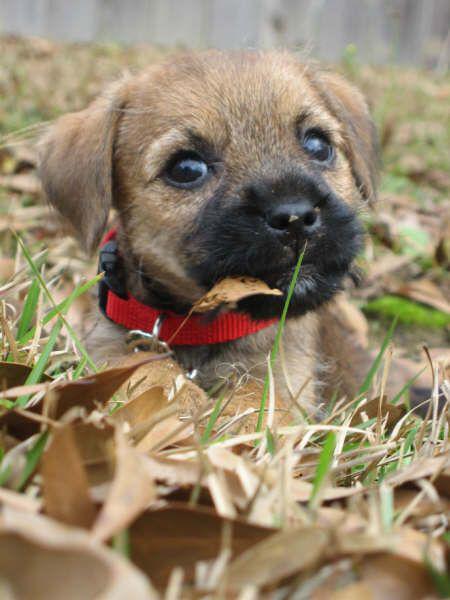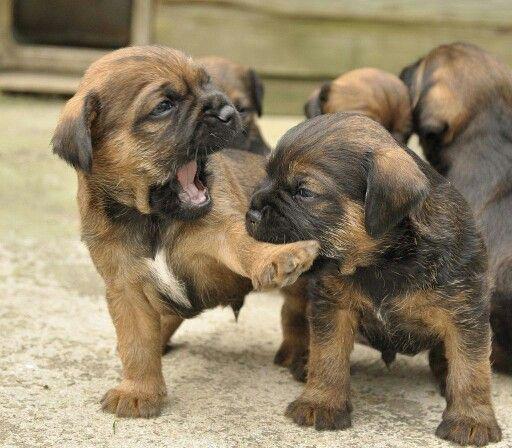The first image is the image on the left, the second image is the image on the right. Analyze the images presented: Is the assertion "Left image shows one dog wearing something colorful around its neck." valid? Answer yes or no. Yes. 